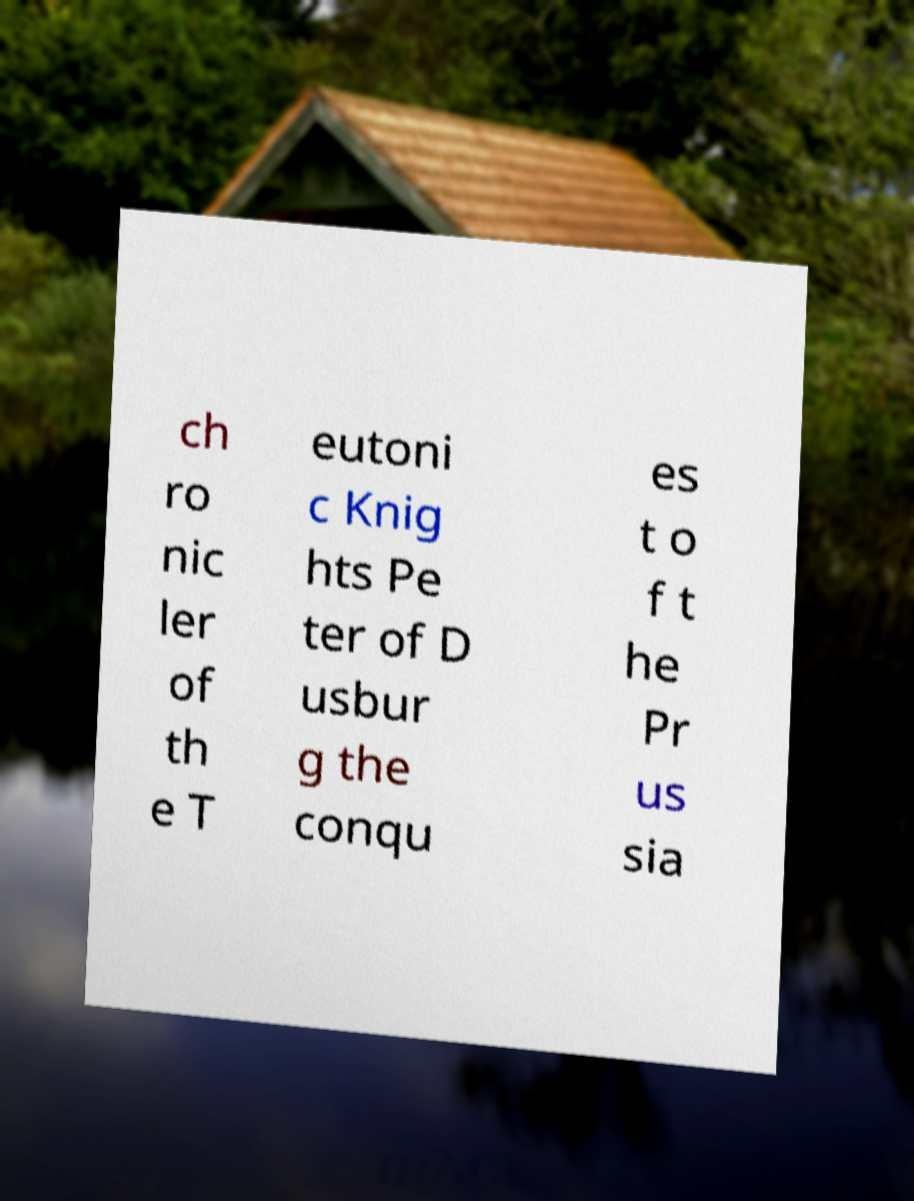Please read and relay the text visible in this image. What does it say? ch ro nic ler of th e T eutoni c Knig hts Pe ter of D usbur g the conqu es t o f t he Pr us sia 